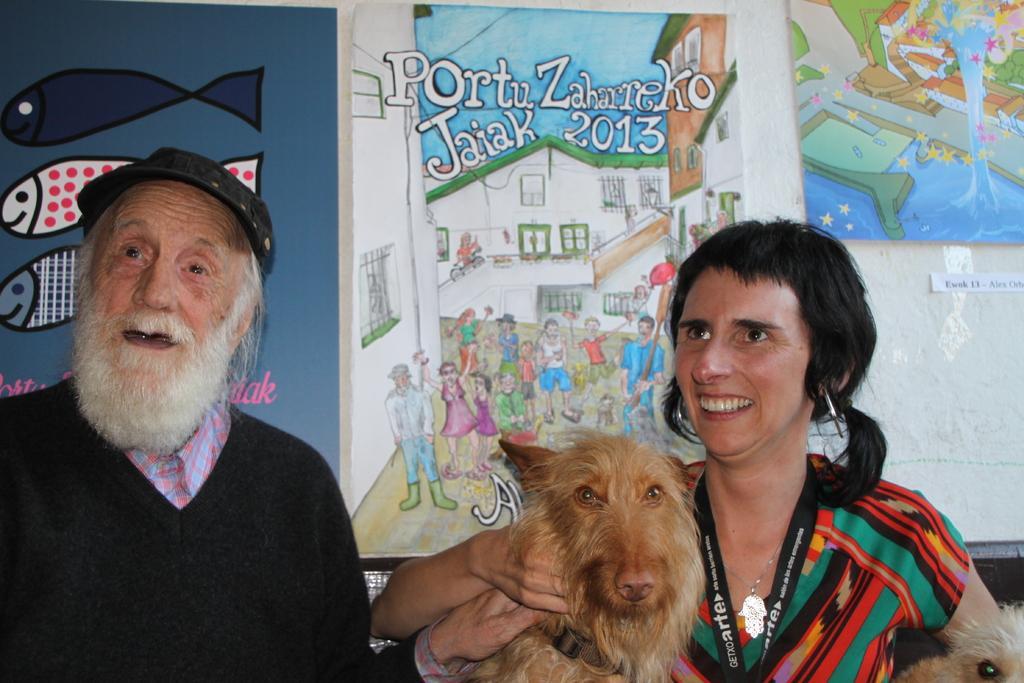How would you summarize this image in a sentence or two? In this picture there is a man with black jacket is standing. And to the right side there is lady. She is standing. She is smiling. And she is holding two dogs in her hands. In the background there are some posters to the wall. 